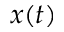<formula> <loc_0><loc_0><loc_500><loc_500>x ( t )</formula> 